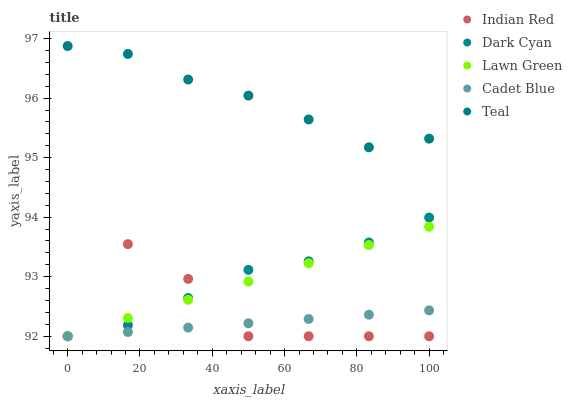Does Cadet Blue have the minimum area under the curve?
Answer yes or no. Yes. Does Teal have the maximum area under the curve?
Answer yes or no. Yes. Does Lawn Green have the minimum area under the curve?
Answer yes or no. No. Does Lawn Green have the maximum area under the curve?
Answer yes or no. No. Is Cadet Blue the smoothest?
Answer yes or no. Yes. Is Indian Red the roughest?
Answer yes or no. Yes. Is Lawn Green the smoothest?
Answer yes or no. No. Is Lawn Green the roughest?
Answer yes or no. No. Does Dark Cyan have the lowest value?
Answer yes or no. Yes. Does Teal have the lowest value?
Answer yes or no. No. Does Teal have the highest value?
Answer yes or no. Yes. Does Lawn Green have the highest value?
Answer yes or no. No. Is Dark Cyan less than Teal?
Answer yes or no. Yes. Is Teal greater than Indian Red?
Answer yes or no. Yes. Does Indian Red intersect Lawn Green?
Answer yes or no. Yes. Is Indian Red less than Lawn Green?
Answer yes or no. No. Is Indian Red greater than Lawn Green?
Answer yes or no. No. Does Dark Cyan intersect Teal?
Answer yes or no. No. 